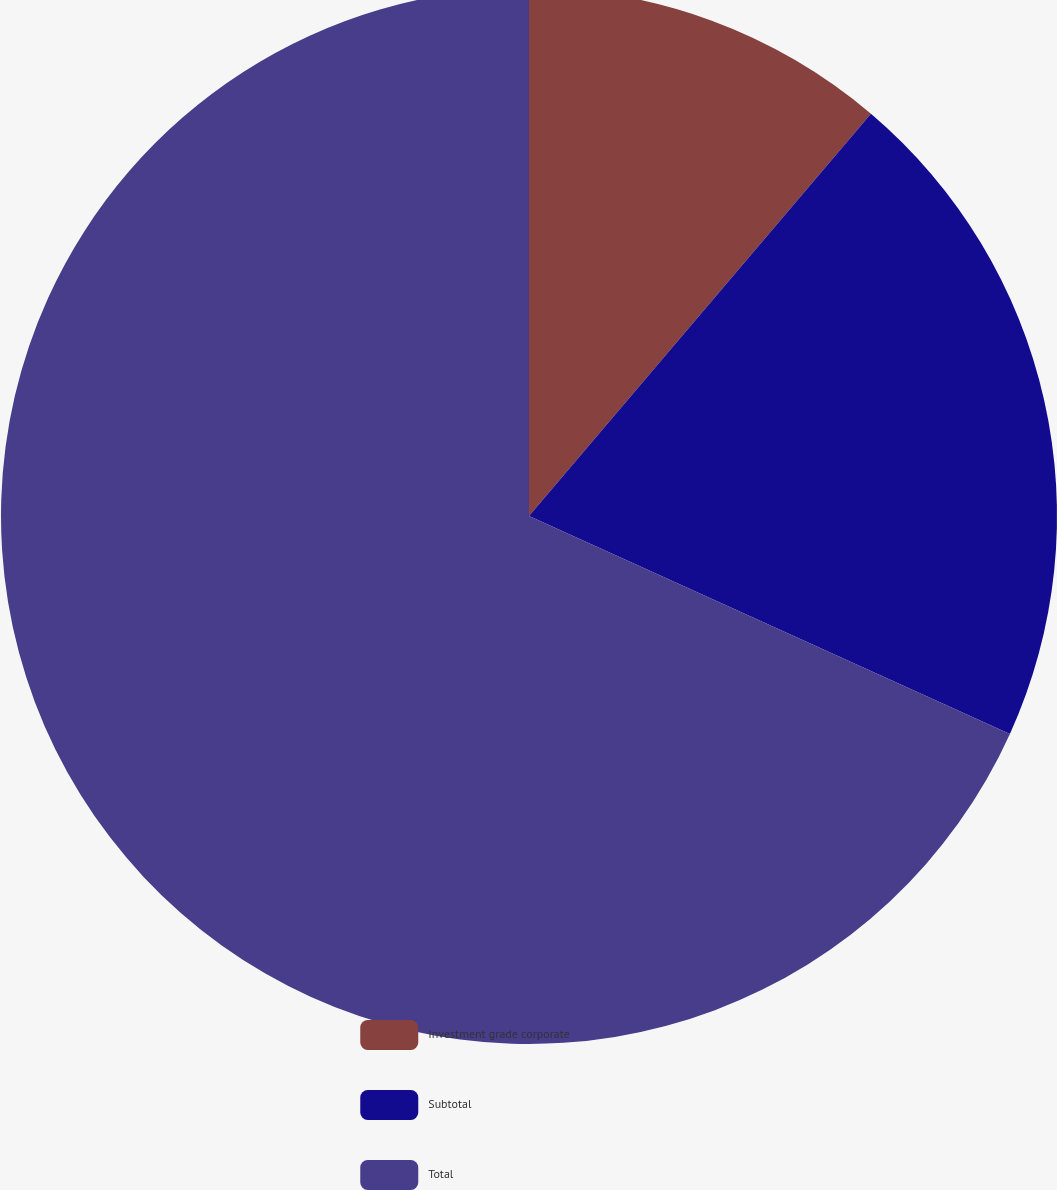<chart> <loc_0><loc_0><loc_500><loc_500><pie_chart><fcel>Investment grade corporate<fcel>Subtotal<fcel>Total<nl><fcel>11.21%<fcel>20.56%<fcel>68.22%<nl></chart> 